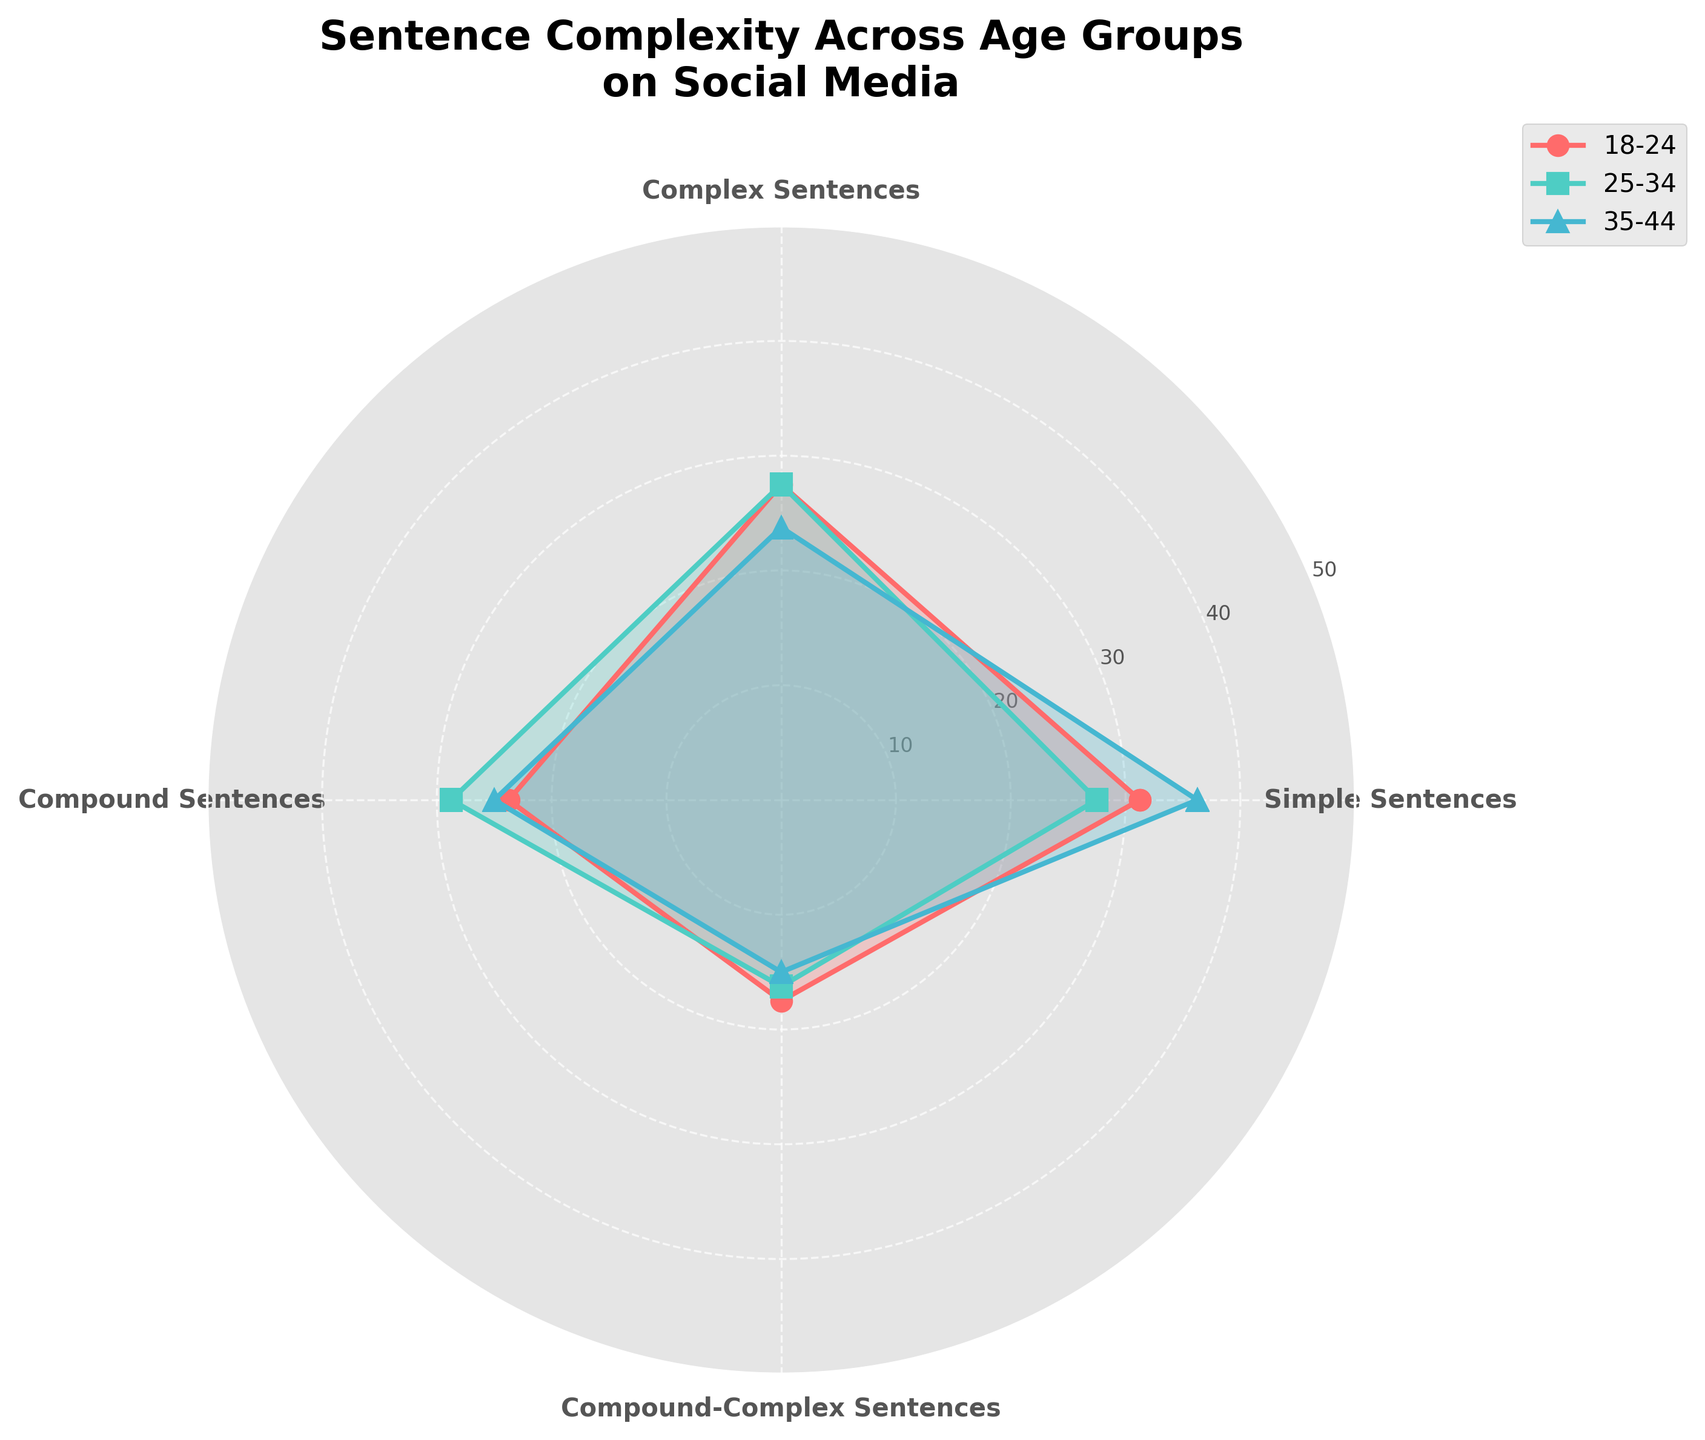What's the title of the radar chart? The title is displayed at the top of the radar chart and summarizes the subject of the figure. It’s “Sentence Complexity Across Age Groups on Social Media.”
Answer: Sentence Complexity Across Age Groups on Social Media Which age group has the highest value for Simple Sentences? By observing the blue line representing the 35-44 age group, we see that it extends to the highest point compared to others in the Simple Sentences category.
Answer: 35-44 What is the range of values on the radial axis? The radial axis ticks show values, ranging from 10 to 50, indicated by the concentric circles.
Answer: 10 to 50 Does any age group have the same average values for Complex Sentences and Compound-Complex Sentences? To find this, look at the lines extending to both Complex Sentences and Compound-Complex Sentences points. The 18-24 age group extends to 25% and 15% respectively for these sentence types, indicating distinct values for each. None of the lines show equal values in these categories.
Answer: No Which age group shows the most variation in values among sentence types? To determine the variation, observe the extent of the differences in lengths of the segments for each age group. The 18-24 age group shows notable fluctuations in segment lengths across sentence types, indicating the highest variation.
Answer: 18-24 Are there any age groups where the value of Compound Sentences exceeds that of Simple Sentences? Compound Sentences are represented by the third segment in each group. Compare these values against Simple Sentences represented by the first segment. In the 35-44 age group, the blue line extends more in the Simple Sentences category, so no age group fulfills this condition.
Answer: No Which age group has the highest average value across all sentence types? To calculate the average, sum the values for each sentence type and divide by the number of sentence types. For example, the values for 35-44 are 45 (Simple) + 20 (Complex) + 20 (Compound) + 15 (Compound-Complex) = 100, divided by 4 equals 25. Repeat for other groups and compare. The 35-44 age group has the highest average.
Answer: 35-44 How does the age group 18-24 compare to the age group 25-34 in terms of Complex Sentences? Compare the second segment representing Complex Sentences for each age group. The 25-34 group posts a higher value at 30% compared to the 18-24 group at 25%.
Answer: 25-34 has higher values 